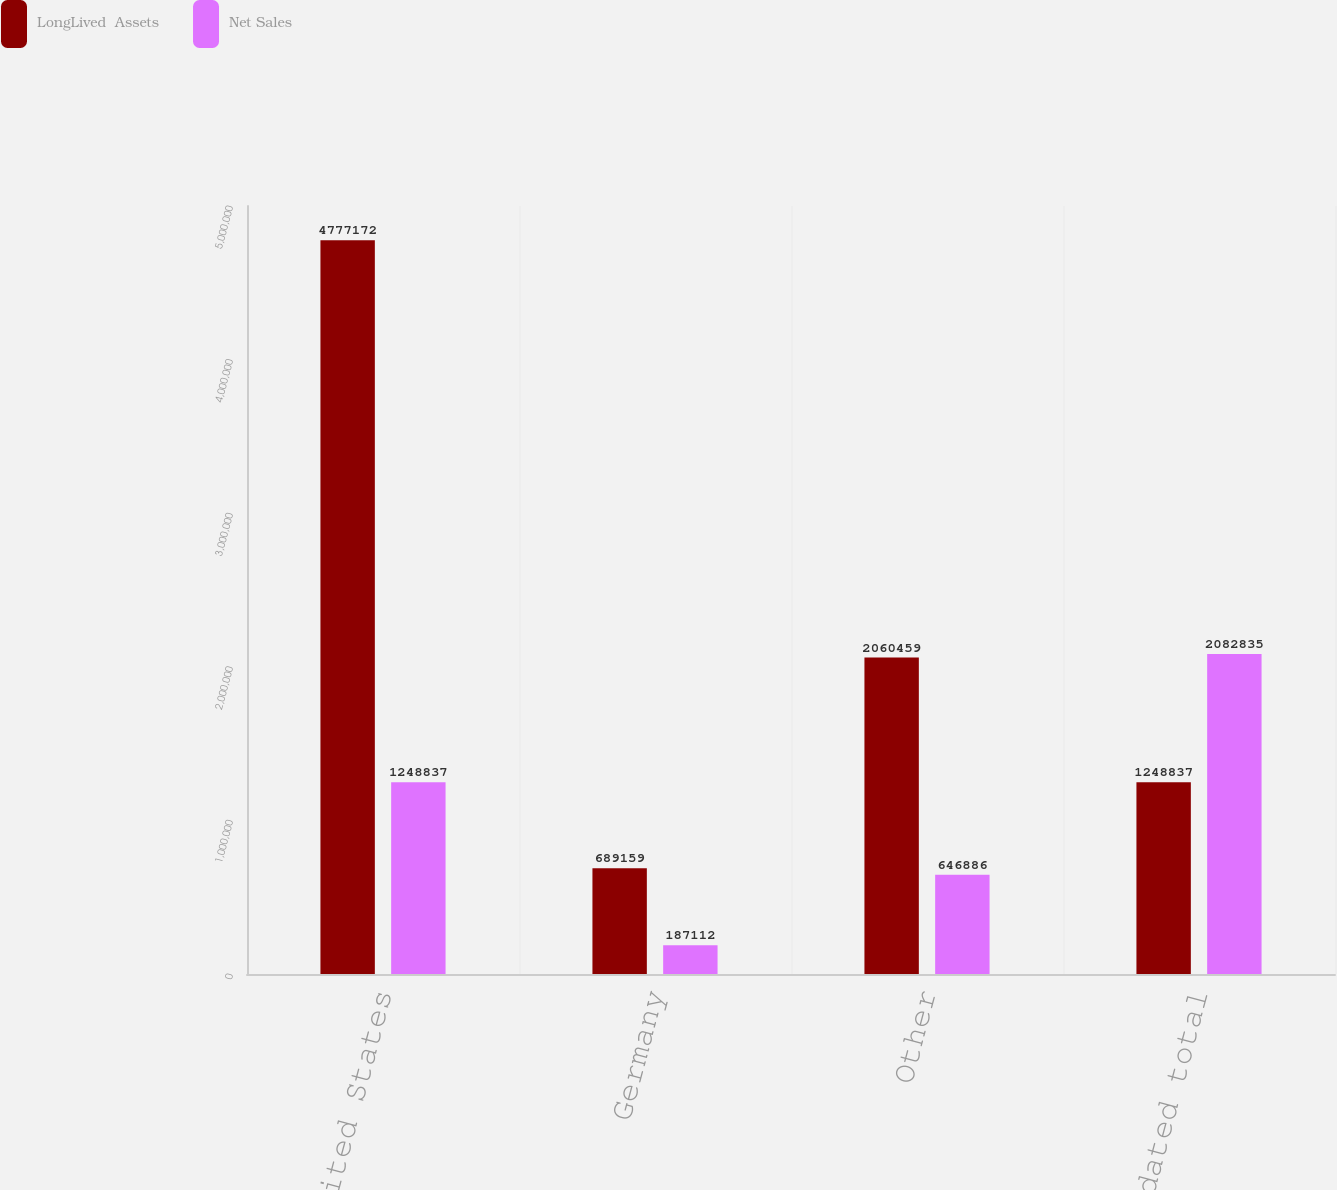Convert chart. <chart><loc_0><loc_0><loc_500><loc_500><stacked_bar_chart><ecel><fcel>United States<fcel>Germany<fcel>Other<fcel>Consolidated total<nl><fcel>LongLived  Assets<fcel>4.77717e+06<fcel>689159<fcel>2.06046e+06<fcel>1.24884e+06<nl><fcel>Net Sales<fcel>1.24884e+06<fcel>187112<fcel>646886<fcel>2.08284e+06<nl></chart> 